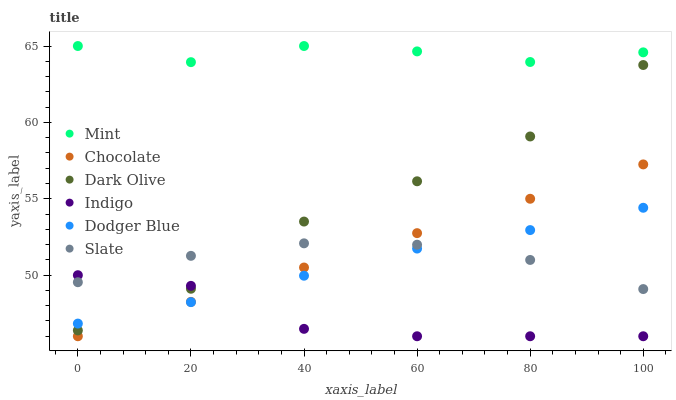Does Indigo have the minimum area under the curve?
Answer yes or no. Yes. Does Mint have the maximum area under the curve?
Answer yes or no. Yes. Does Slate have the minimum area under the curve?
Answer yes or no. No. Does Slate have the maximum area under the curve?
Answer yes or no. No. Is Chocolate the smoothest?
Answer yes or no. Yes. Is Dark Olive the roughest?
Answer yes or no. Yes. Is Slate the smoothest?
Answer yes or no. No. Is Slate the roughest?
Answer yes or no. No. Does Indigo have the lowest value?
Answer yes or no. Yes. Does Slate have the lowest value?
Answer yes or no. No. Does Mint have the highest value?
Answer yes or no. Yes. Does Slate have the highest value?
Answer yes or no. No. Is Dodger Blue less than Mint?
Answer yes or no. Yes. Is Mint greater than Dodger Blue?
Answer yes or no. Yes. Does Dark Olive intersect Dodger Blue?
Answer yes or no. Yes. Is Dark Olive less than Dodger Blue?
Answer yes or no. No. Is Dark Olive greater than Dodger Blue?
Answer yes or no. No. Does Dodger Blue intersect Mint?
Answer yes or no. No. 